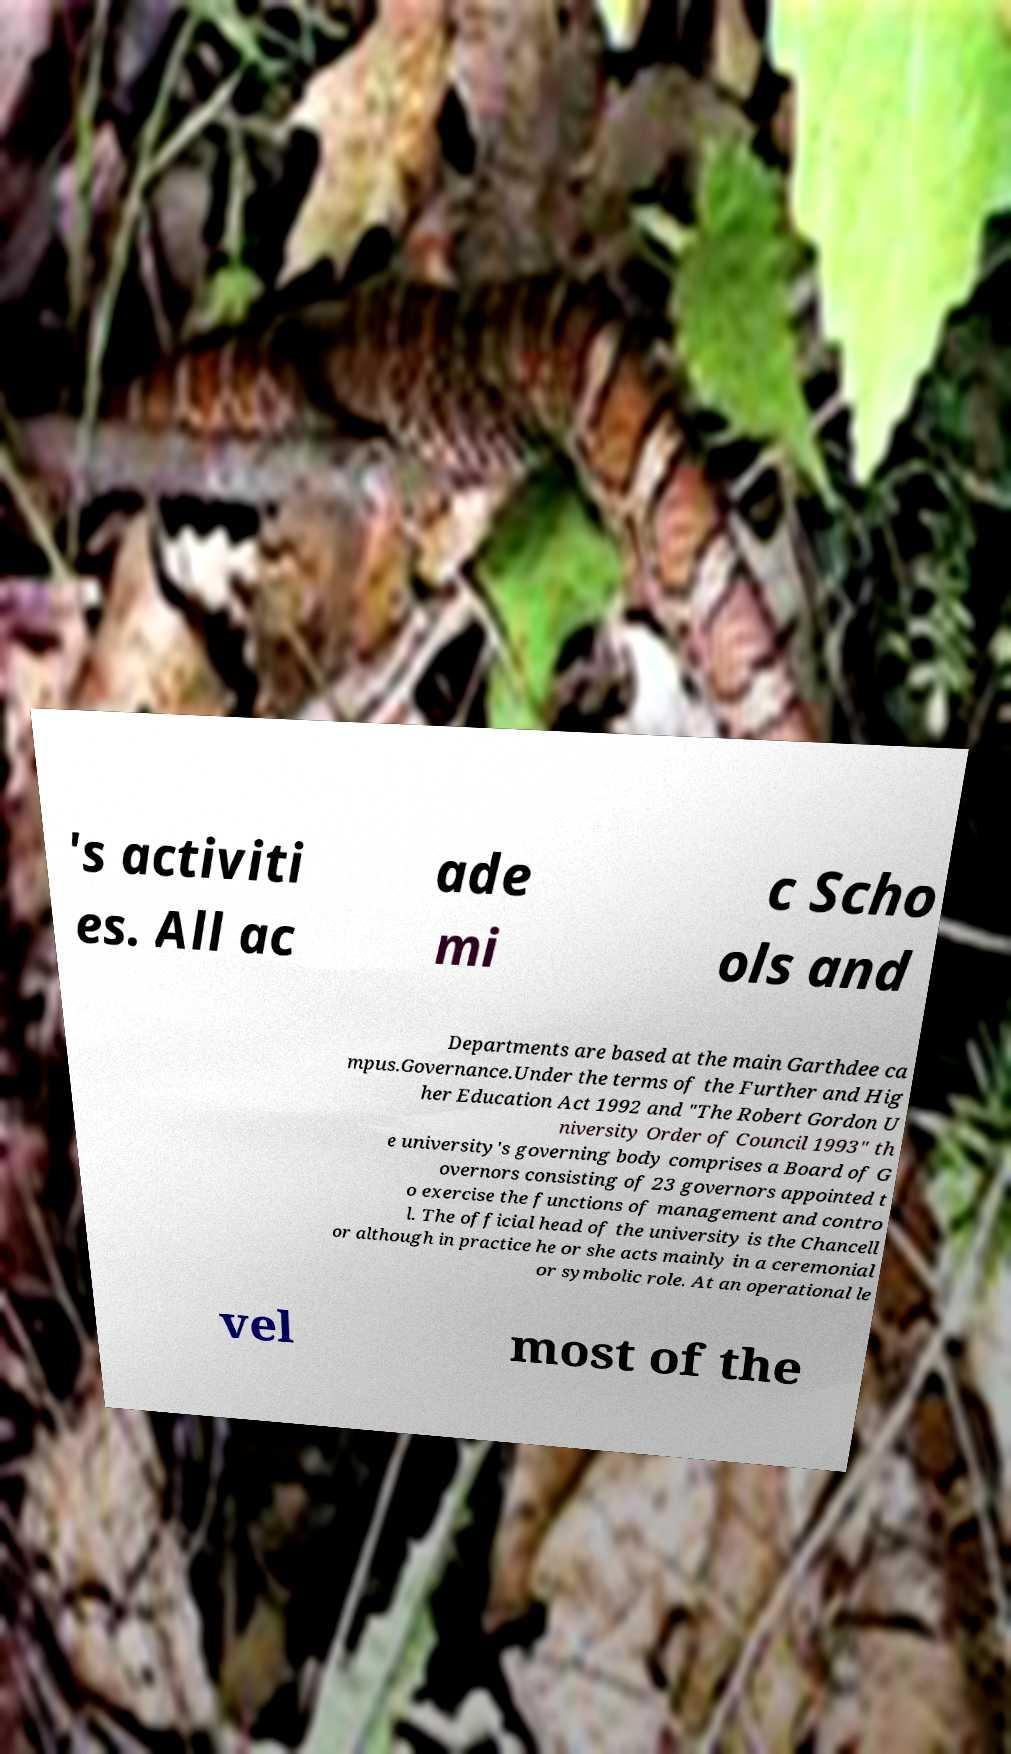For documentation purposes, I need the text within this image transcribed. Could you provide that? 's activiti es. All ac ade mi c Scho ols and Departments are based at the main Garthdee ca mpus.Governance.Under the terms of the Further and Hig her Education Act 1992 and "The Robert Gordon U niversity Order of Council 1993" th e university's governing body comprises a Board of G overnors consisting of 23 governors appointed t o exercise the functions of management and contro l. The official head of the university is the Chancell or although in practice he or she acts mainly in a ceremonial or symbolic role. At an operational le vel most of the 